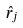<formula> <loc_0><loc_0><loc_500><loc_500>\hat { r } _ { j }</formula> 